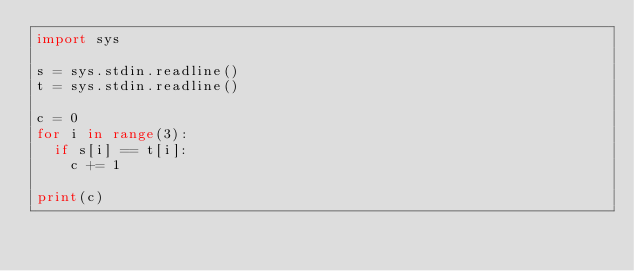Convert code to text. <code><loc_0><loc_0><loc_500><loc_500><_Python_>import sys

s = sys.stdin.readline()
t = sys.stdin.readline()

c = 0
for i in range(3):
  if s[i] == t[i]:
    c += 1
    
print(c)</code> 